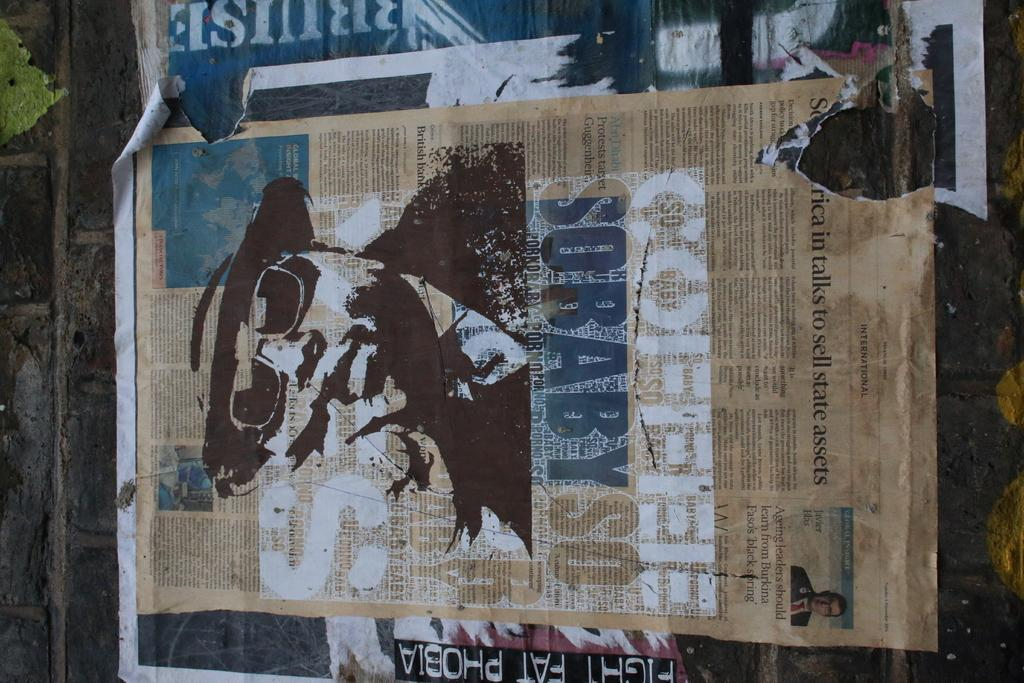What is present on the wall in the image? There is a poster in the image. How is the poster attached to the wall? The poster is pasted on the wall. What does the poster resemble in the image? The poster resembles a newspaper. Can you tell me how many pickles are on the poster in the image? There are no pickles present on the poster in the image. Is there a stranger standing next to the poster in the image? There is no stranger present in the image. 